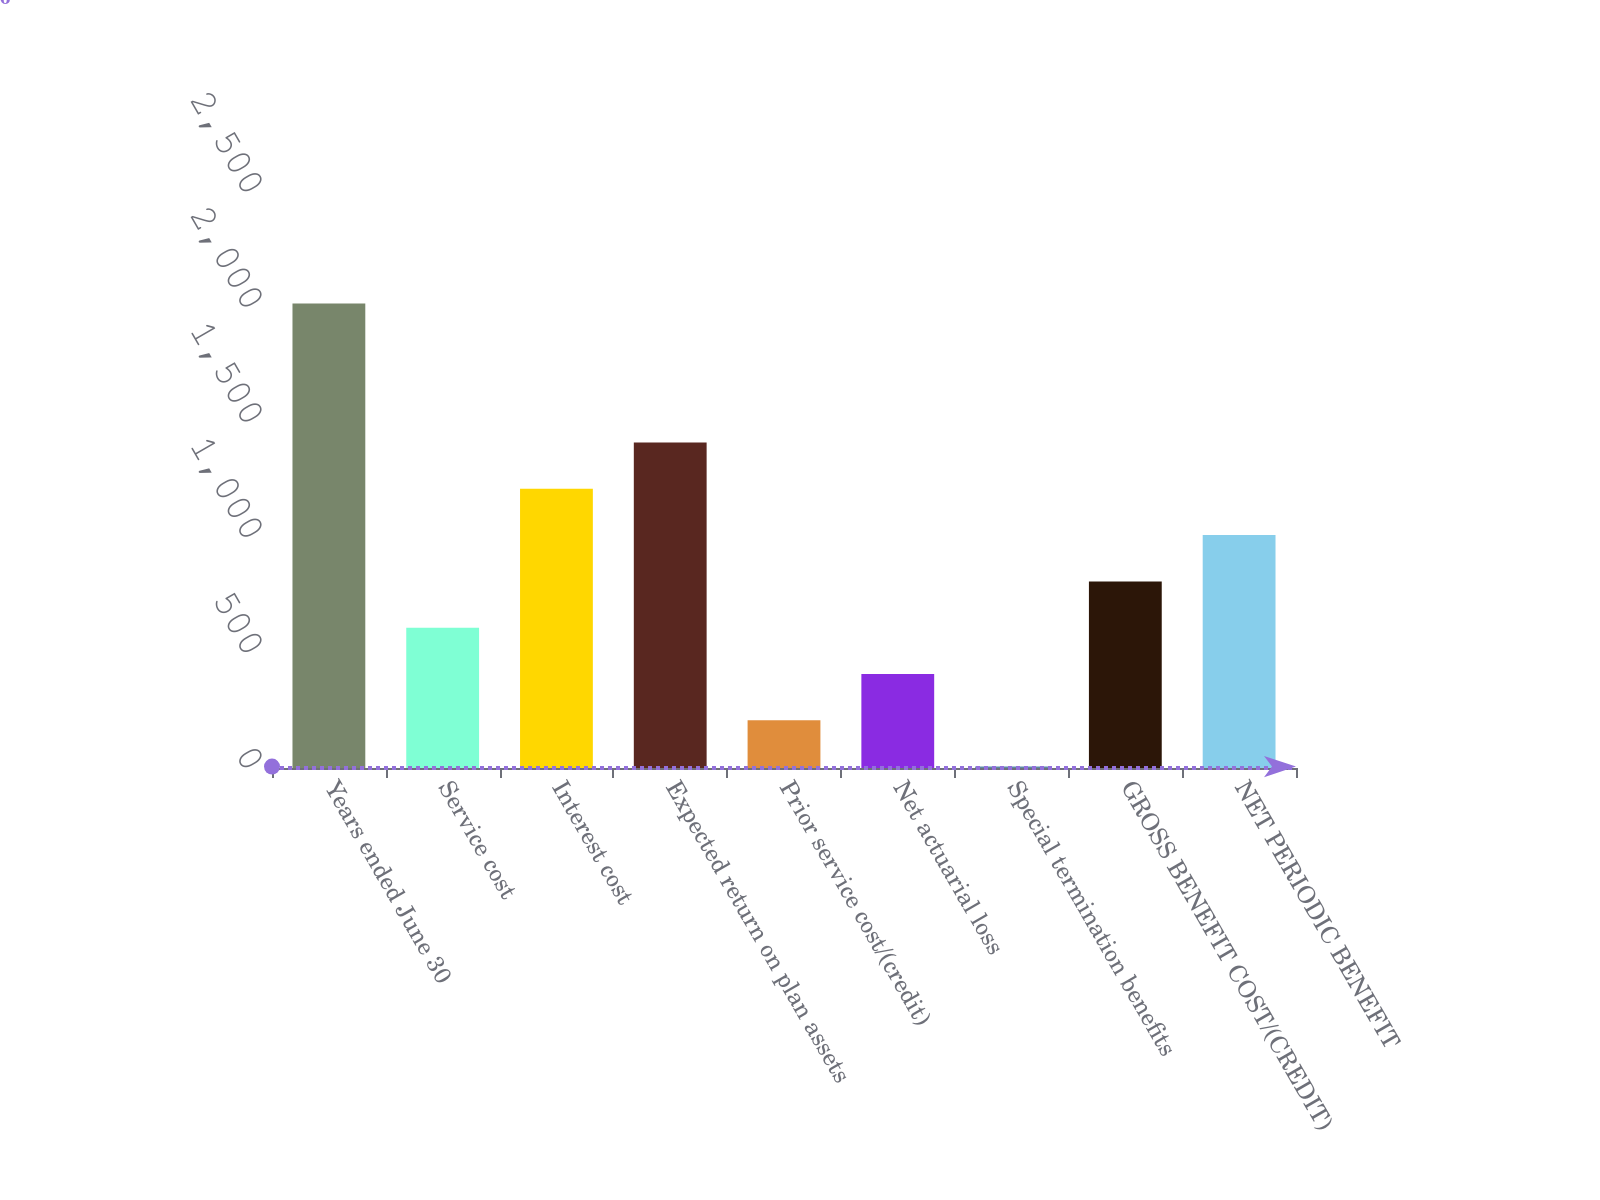<chart> <loc_0><loc_0><loc_500><loc_500><bar_chart><fcel>Years ended June 30<fcel>Service cost<fcel>Interest cost<fcel>Expected return on plan assets<fcel>Prior service cost/(credit)<fcel>Net actuarial loss<fcel>Special termination benefits<fcel>GROSS BENEFIT COST/(CREDIT)<fcel>NET PERIODIC BENEFIT<nl><fcel>2016<fcel>609<fcel>1212<fcel>1413<fcel>207<fcel>408<fcel>6<fcel>810<fcel>1011<nl></chart> 